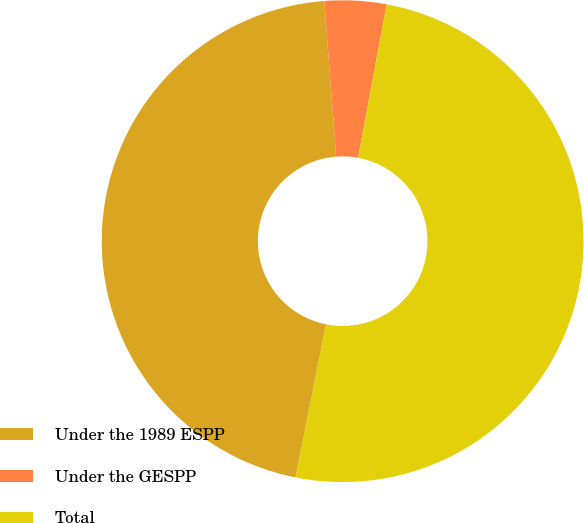<chart> <loc_0><loc_0><loc_500><loc_500><pie_chart><fcel>Under the 1989 ESPP<fcel>Under the GESPP<fcel>Total<nl><fcel>45.65%<fcel>4.14%<fcel>50.21%<nl></chart> 